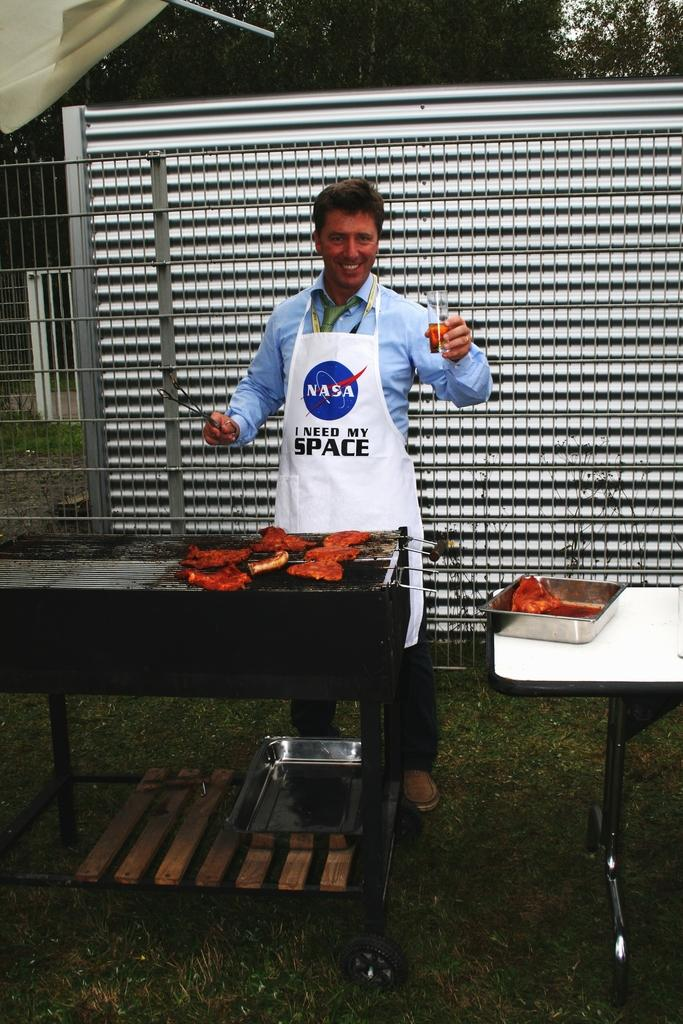<image>
Write a terse but informative summary of the picture. A man is grilling while wearing a NASA apron. 